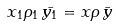<formula> <loc_0><loc_0><loc_500><loc_500>x _ { 1 } \rho _ { 1 } \, \bar { y _ { 1 } } = x \rho \, \bar { y }</formula> 